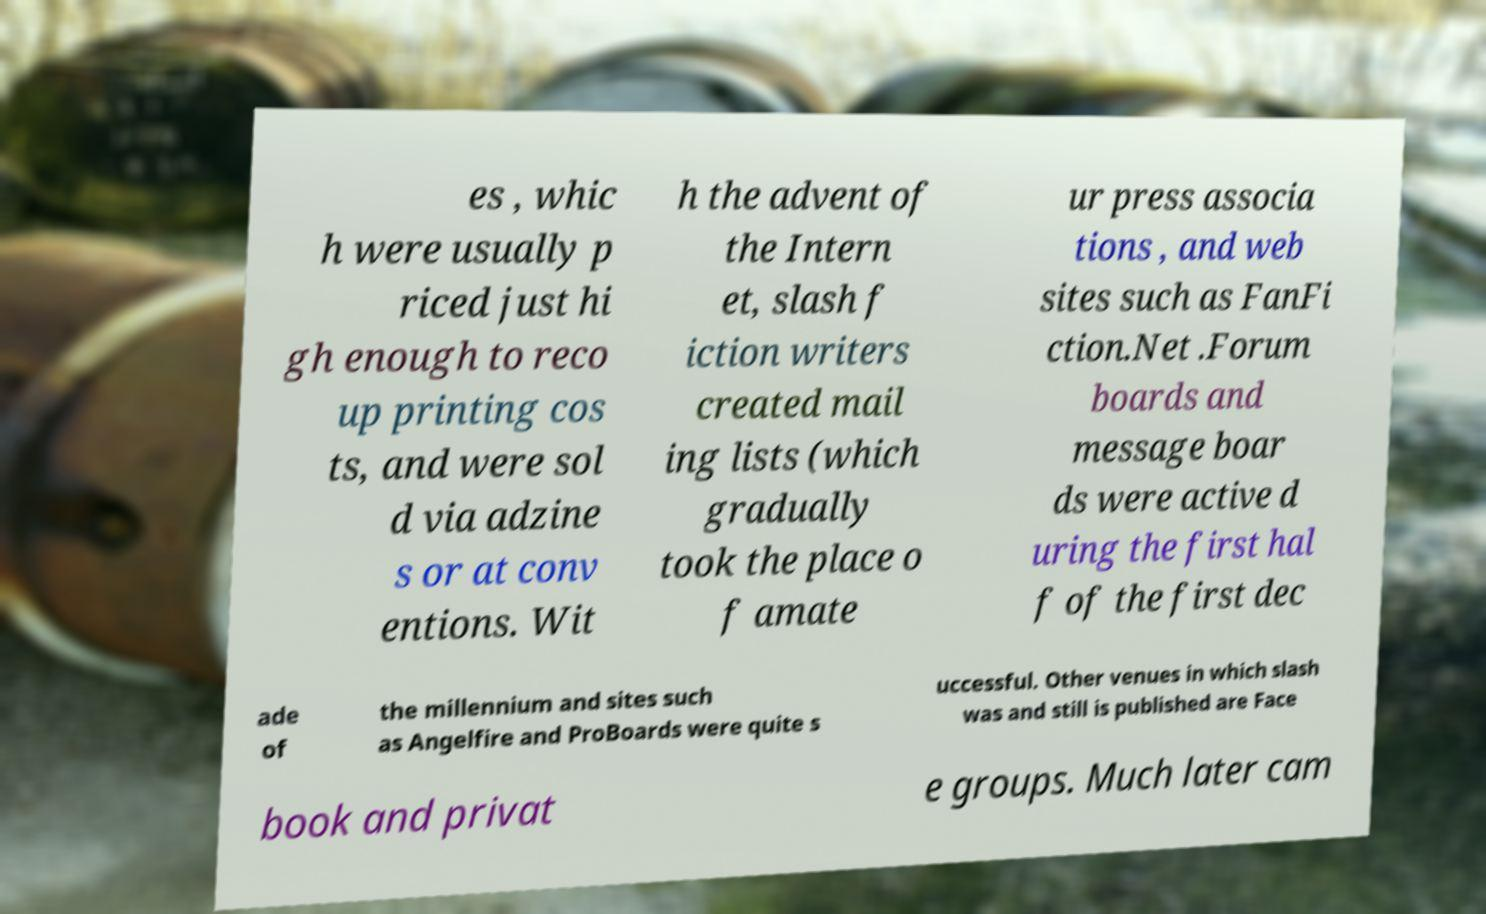Please identify and transcribe the text found in this image. es , whic h were usually p riced just hi gh enough to reco up printing cos ts, and were sol d via adzine s or at conv entions. Wit h the advent of the Intern et, slash f iction writers created mail ing lists (which gradually took the place o f amate ur press associa tions , and web sites such as FanFi ction.Net .Forum boards and message boar ds were active d uring the first hal f of the first dec ade of the millennium and sites such as Angelfire and ProBoards were quite s uccessful. Other venues in which slash was and still is published are Face book and privat e groups. Much later cam 